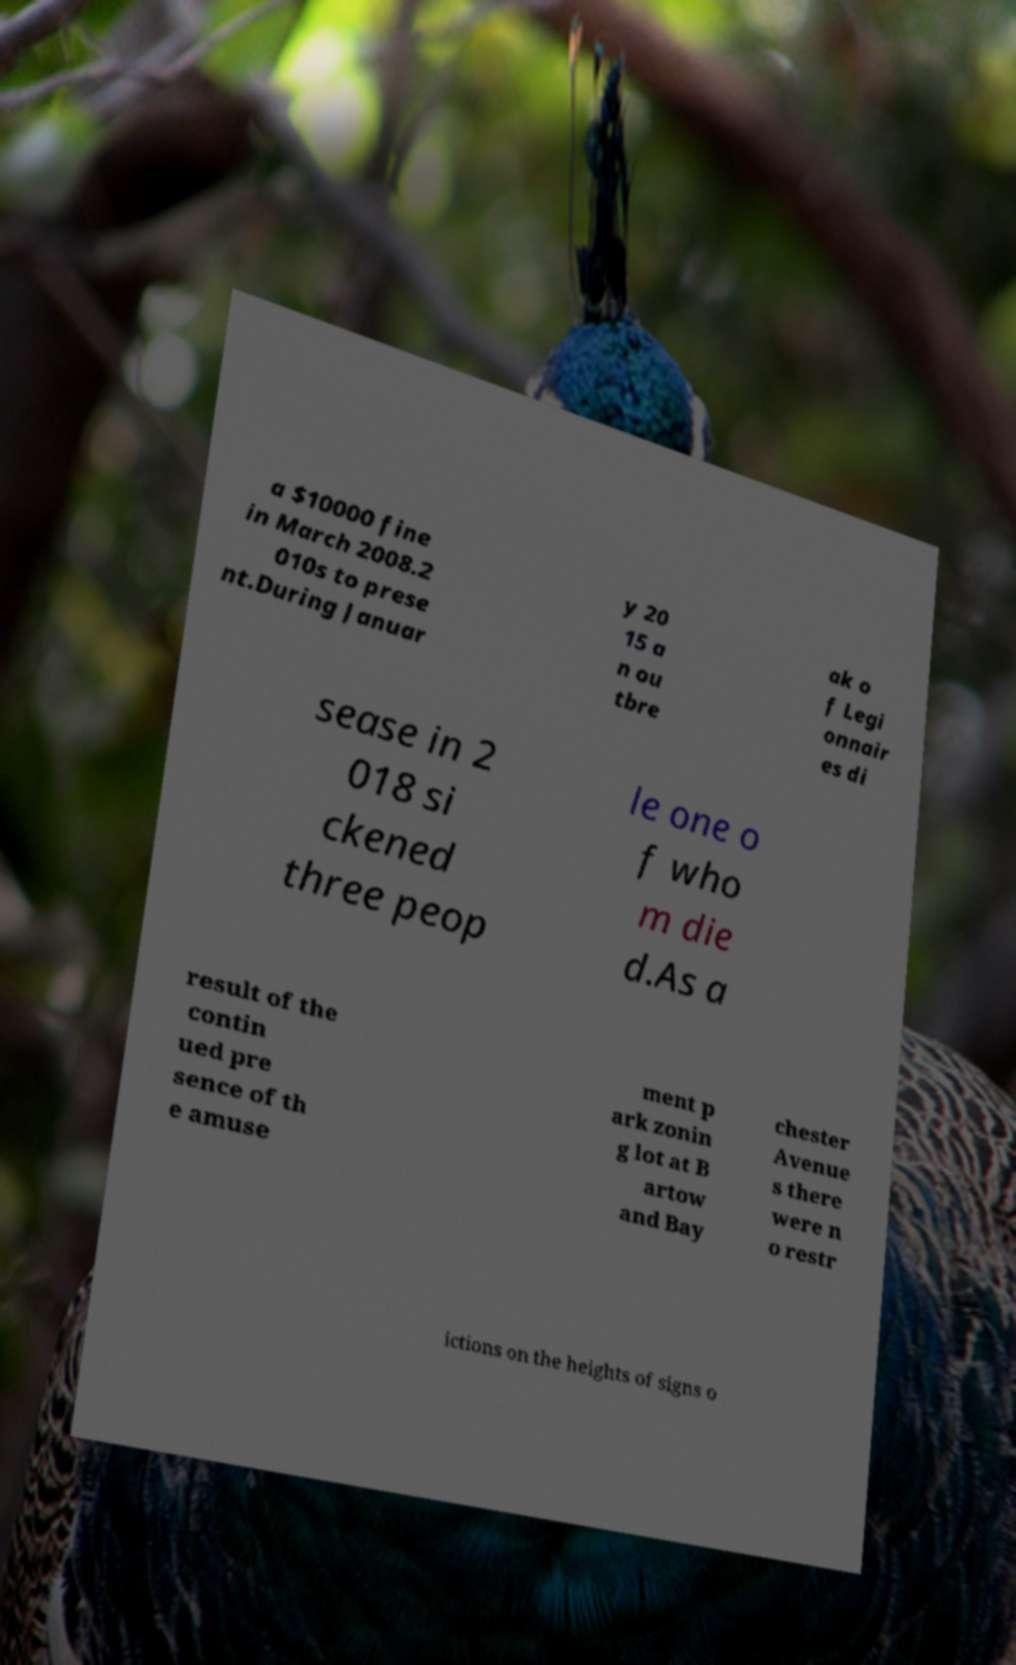Can you read and provide the text displayed in the image?This photo seems to have some interesting text. Can you extract and type it out for me? a $10000 fine in March 2008.2 010s to prese nt.During Januar y 20 15 a n ou tbre ak o f Legi onnair es di sease in 2 018 si ckened three peop le one o f who m die d.As a result of the contin ued pre sence of th e amuse ment p ark zonin g lot at B artow and Bay chester Avenue s there were n o restr ictions on the heights of signs o 